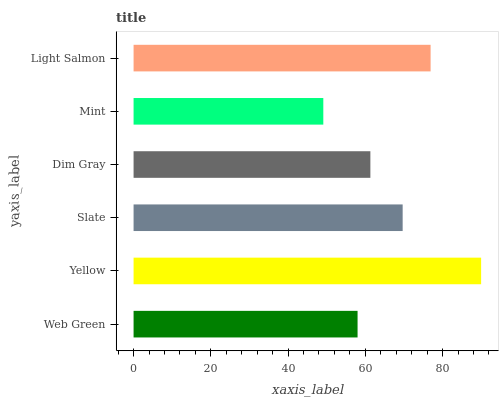Is Mint the minimum?
Answer yes or no. Yes. Is Yellow the maximum?
Answer yes or no. Yes. Is Slate the minimum?
Answer yes or no. No. Is Slate the maximum?
Answer yes or no. No. Is Yellow greater than Slate?
Answer yes or no. Yes. Is Slate less than Yellow?
Answer yes or no. Yes. Is Slate greater than Yellow?
Answer yes or no. No. Is Yellow less than Slate?
Answer yes or no. No. Is Slate the high median?
Answer yes or no. Yes. Is Dim Gray the low median?
Answer yes or no. Yes. Is Web Green the high median?
Answer yes or no. No. Is Light Salmon the low median?
Answer yes or no. No. 